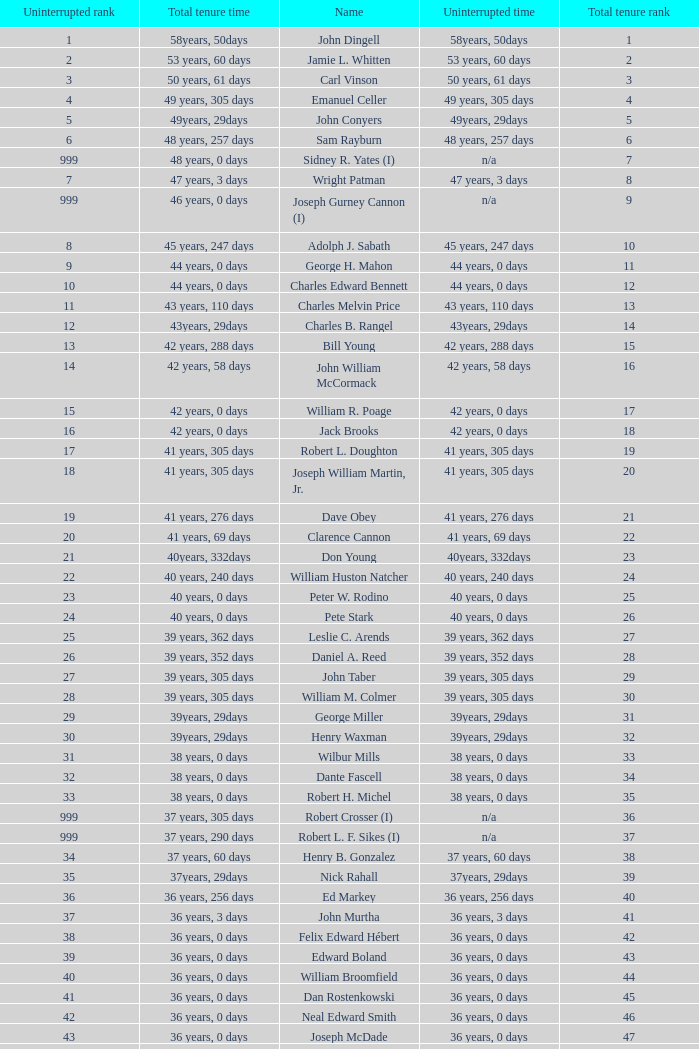Who has a total tenure time and uninterrupted time of 36 years, 0 days, as well as a total tenure rank of 49? James Oberstar. 